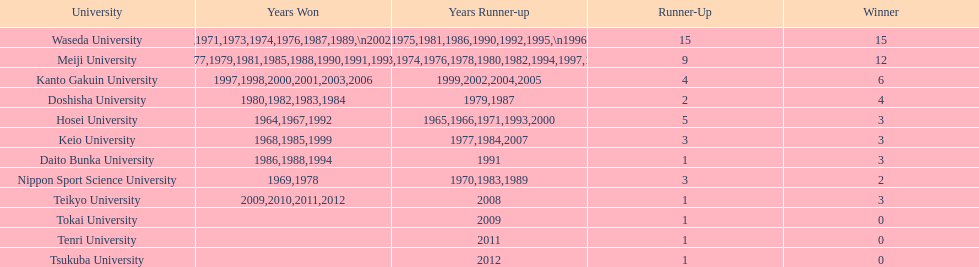I'm looking to parse the entire table for insights. Could you assist me with that? {'header': ['University', 'Years Won', 'Years Runner-up', 'Runner-Up', 'Winner'], 'rows': [['Waseda University', '1965,1966,1968,1970,1971,1973,1974,1976,1987,1989,\\n2002,2004,2005,2007,2008', '1964,1967,1969,1972,1975,1981,1986,1990,1992,1995,\\n1996,2001,2003,2006,2010', '15', '15'], ['Meiji University', '1972,1975,1977,1979,1981,1985,1988,1990,1991,1993,\\n1995,1996', '1973,1974,1976,1978,1980,1982,1994,1997,1998', '9', '12'], ['Kanto Gakuin University', '1997,1998,2000,2001,2003,2006', '1999,2002,2004,2005', '4', '6'], ['Doshisha University', '1980,1982,1983,1984', '1979,1987', '2', '4'], ['Hosei University', '1964,1967,1992', '1965,1966,1971,1993,2000', '5', '3'], ['Keio University', '1968,1985,1999', '1977,1984,2007', '3', '3'], ['Daito Bunka University', '1986,1988,1994', '1991', '1', '3'], ['Nippon Sport Science University', '1969,1978', '1970,1983,1989', '3', '2'], ['Teikyo University', '2009,2010,2011,2012', '2008', '1', '3'], ['Tokai University', '', '2009', '1', '0'], ['Tenri University', '', '2011', '1', '0'], ['Tsukuba University', '', '2012', '1', '0']]} Which universities had a number of wins higher than 12? Waseda University. 